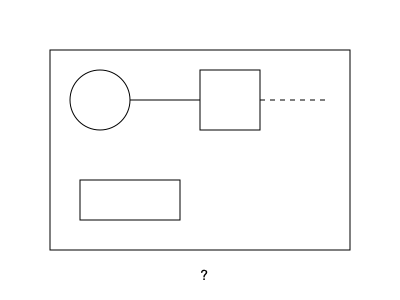Based on the technical blueprint shown, which critical component is missing from the machinery setup? 1. Analyze the blueprint components:
   - Large rectangular frame (outer boundary)
   - Circular component on the left (likely a gear or pulley)
   - Square component in the center (possibly a motor or control unit)
   - Rectangular component at the bottom (could be a base or support structure)

2. Observe the connections:
   - Solid line connecting the circular component to the square component
   - Dashed line extending from the square component to the right side

3. Identify the missing element:
   - The dashed line suggests an intended connection or extension
   - No component is present at the end of the dashed line

4. Consider the function:
   - Given the circular component (possible input) and central square (possible processing unit), the missing component likely represents an output or end effector

5. Conclusion:
   - The missing component is likely an end effector or output mechanism, such as a robotic arm, tool, or secondary gear system
Answer: End effector/output mechanism 